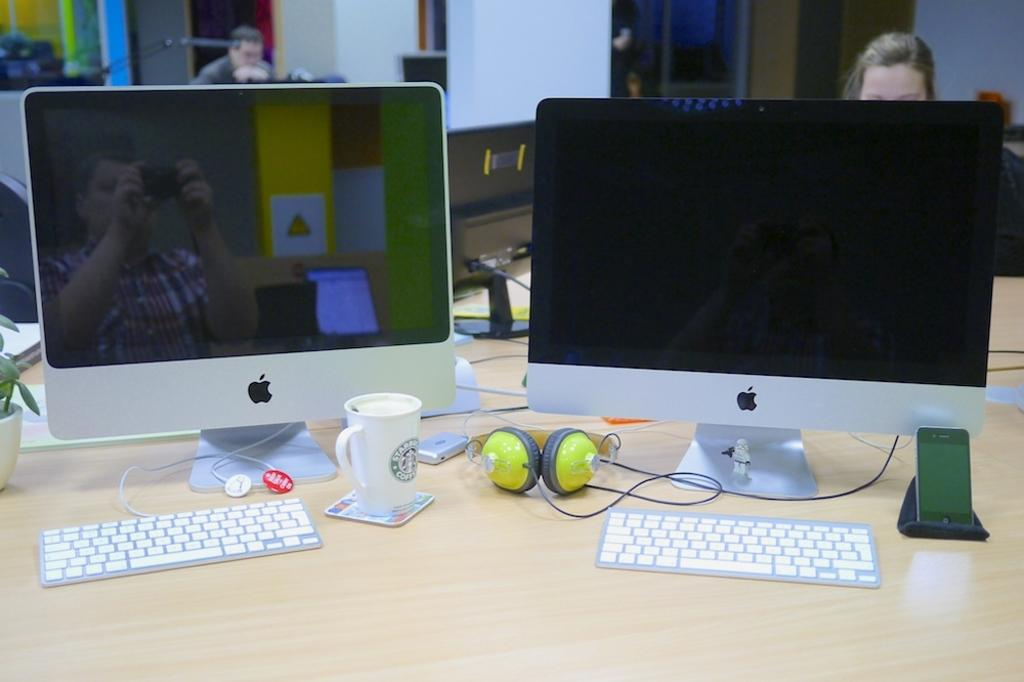What piece of furniture is in the image? There is a table in the image. What electronic devices are on the table? There are two computers, keyboards, a glass, headsets, and a mobile phone on the table. Can you describe the people in the background? There are people sitting in the background. What can be seen in the distance behind the table? There is a building in the background. What type of cabbage is being used as a headset in the image? There is no cabbage present in the image, and no cabbage is being used as a headset. 